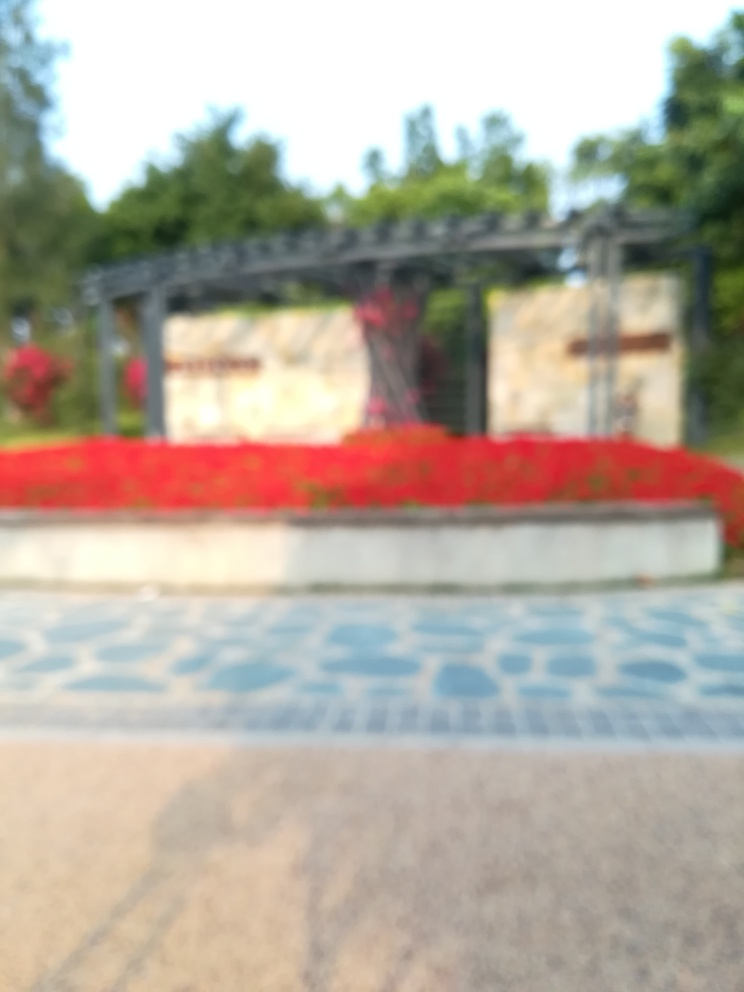Can you describe the color scheme of the image? Despite the image being out of focus, we can observe a dominant red color, possibly from flowers or a similar feature, contrasting with greenery in the background that suggests a natural or a garden setting. There's also a glimpse of blue patterns on the ground, indicating a pathway or decorative tiles. 